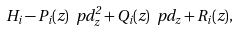<formula> <loc_0><loc_0><loc_500><loc_500>H _ { i } - P _ { i } ( z ) \ p d _ { z } ^ { 2 } + Q _ { i } ( z ) \ p d _ { z } + R _ { i } ( z ) ,</formula> 